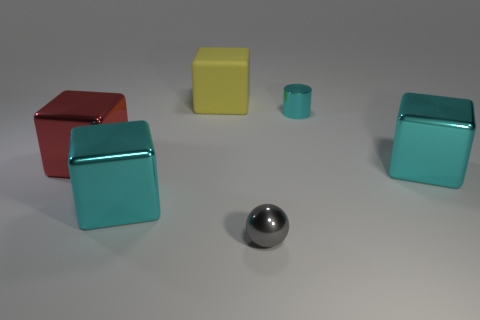What can you tell me about the color palette in this image? The image features a muted color palette with objects in red, yellow, turquoise, and gray. These colors create a sense of calm and balance without any strong contrasts, apart from the red cube that stands out due to its more vibrant hue. 